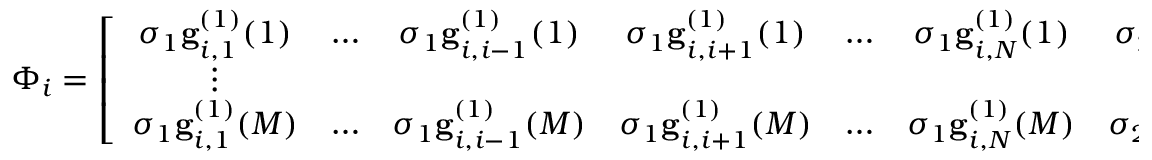<formula> <loc_0><loc_0><loc_500><loc_500>\Phi _ { i } = \left [ \begin{array} { c c c c c c c c c } { \sigma _ { 1 } g _ { i , 1 } ^ { ( 1 ) } ( 1 ) } & { \dots } & { \sigma _ { 1 } g _ { i , i - 1 } ^ { ( 1 ) } ( 1 ) } & { \sigma _ { 1 } g _ { i , i + 1 } ^ { ( 1 ) } ( 1 ) } & { \dots } & { \sigma _ { 1 } g _ { i , N } ^ { ( 1 ) } ( 1 ) } & { \sigma _ { 2 } g _ { i , 1 , 2 } ^ { ( 2 ) } ( 1 ) } & { \dots } & { \sigma _ { D } g _ { i , N - D + 1 , \dots , N } ^ { ( D ) } ( 1 ) } \\ { \vdots } & { \vdots } \\ { \sigma _ { 1 } g _ { i , 1 } ^ { ( 1 ) } ( M ) } & { \dots } & { \sigma _ { 1 } g _ { i , i - 1 } ^ { ( 1 ) } ( M ) } & { \sigma _ { 1 } g _ { i , i + 1 } ^ { ( 1 ) } ( M ) } & { \dots } & { \sigma _ { 1 } g _ { i , N } ^ { ( 1 ) } ( M ) } & { \sigma _ { 2 } g _ { i , 1 , 2 } ^ { ( 2 ) } ( M ) } & { \dots } & { \sigma _ { D } g _ { i , N - D + 1 , \dots , N } ^ { ( D ) } ( M ) } \end{array} \right ]</formula> 